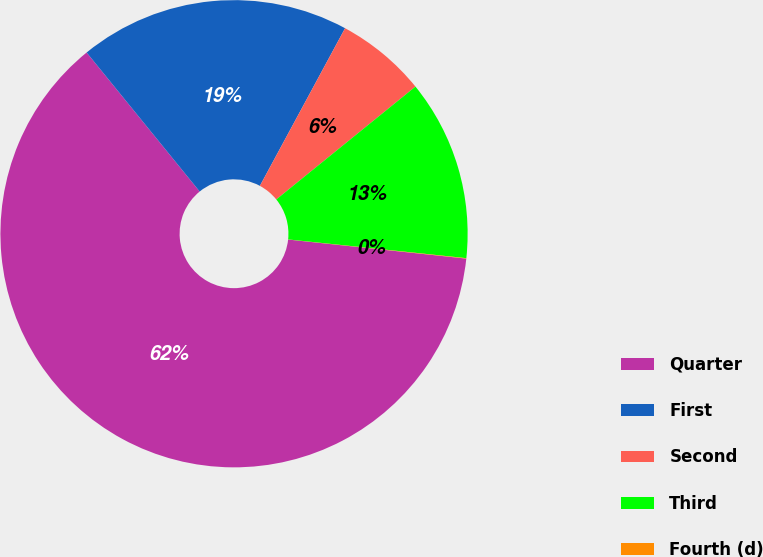Convert chart to OTSL. <chart><loc_0><loc_0><loc_500><loc_500><pie_chart><fcel>Quarter<fcel>First<fcel>Second<fcel>Third<fcel>Fourth (d)<nl><fcel>62.43%<fcel>18.75%<fcel>6.27%<fcel>12.51%<fcel>0.03%<nl></chart> 